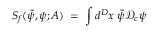<formula> <loc_0><loc_0><loc_500><loc_500>S _ { f } ( { \bar { \psi } } , \psi ; A ) \, = \, \int d ^ { D } x \, { \bar { \psi } } { \mathcal { D } } _ { c } \psi</formula> 